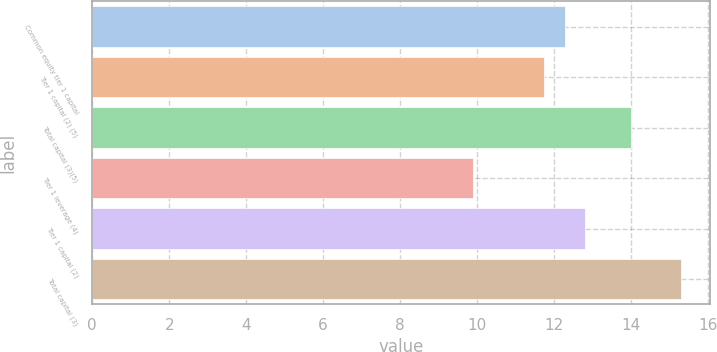<chart> <loc_0><loc_0><loc_500><loc_500><bar_chart><fcel>Common equity tier 1 capital<fcel>Tier 1 capital (2) (5)<fcel>Total capital (3)(5)<fcel>Tier 1 leverage (4)<fcel>Tier 1 capital (2)<fcel>Total capital (3)<nl><fcel>12.28<fcel>11.74<fcel>14<fcel>9.9<fcel>12.82<fcel>15.3<nl></chart> 